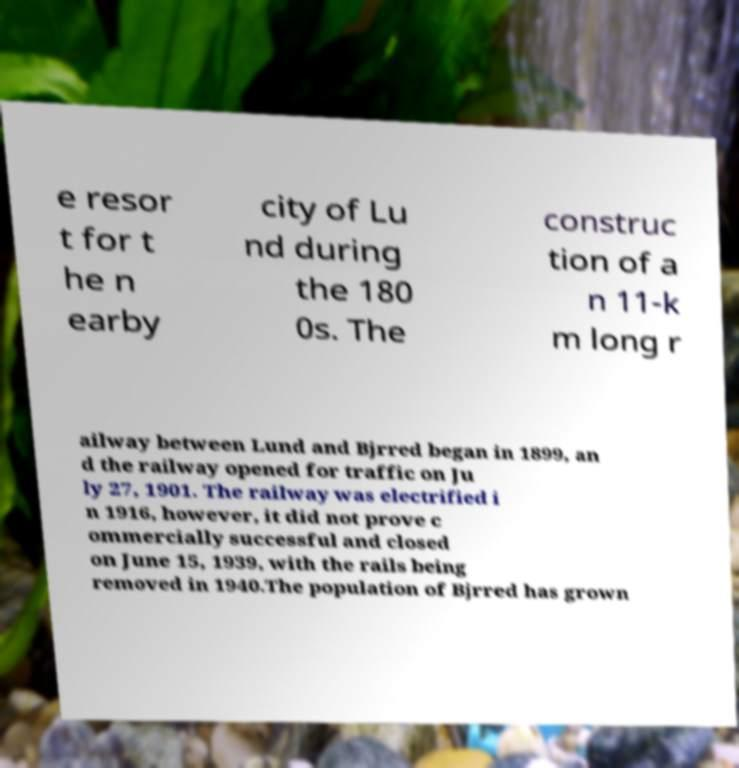There's text embedded in this image that I need extracted. Can you transcribe it verbatim? e resor t for t he n earby city of Lu nd during the 180 0s. The construc tion of a n 11-k m long r ailway between Lund and Bjrred began in 1899, an d the railway opened for traffic on Ju ly 27, 1901. The railway was electrified i n 1916, however, it did not prove c ommercially successful and closed on June 15, 1939, with the rails being removed in 1940.The population of Bjrred has grown 